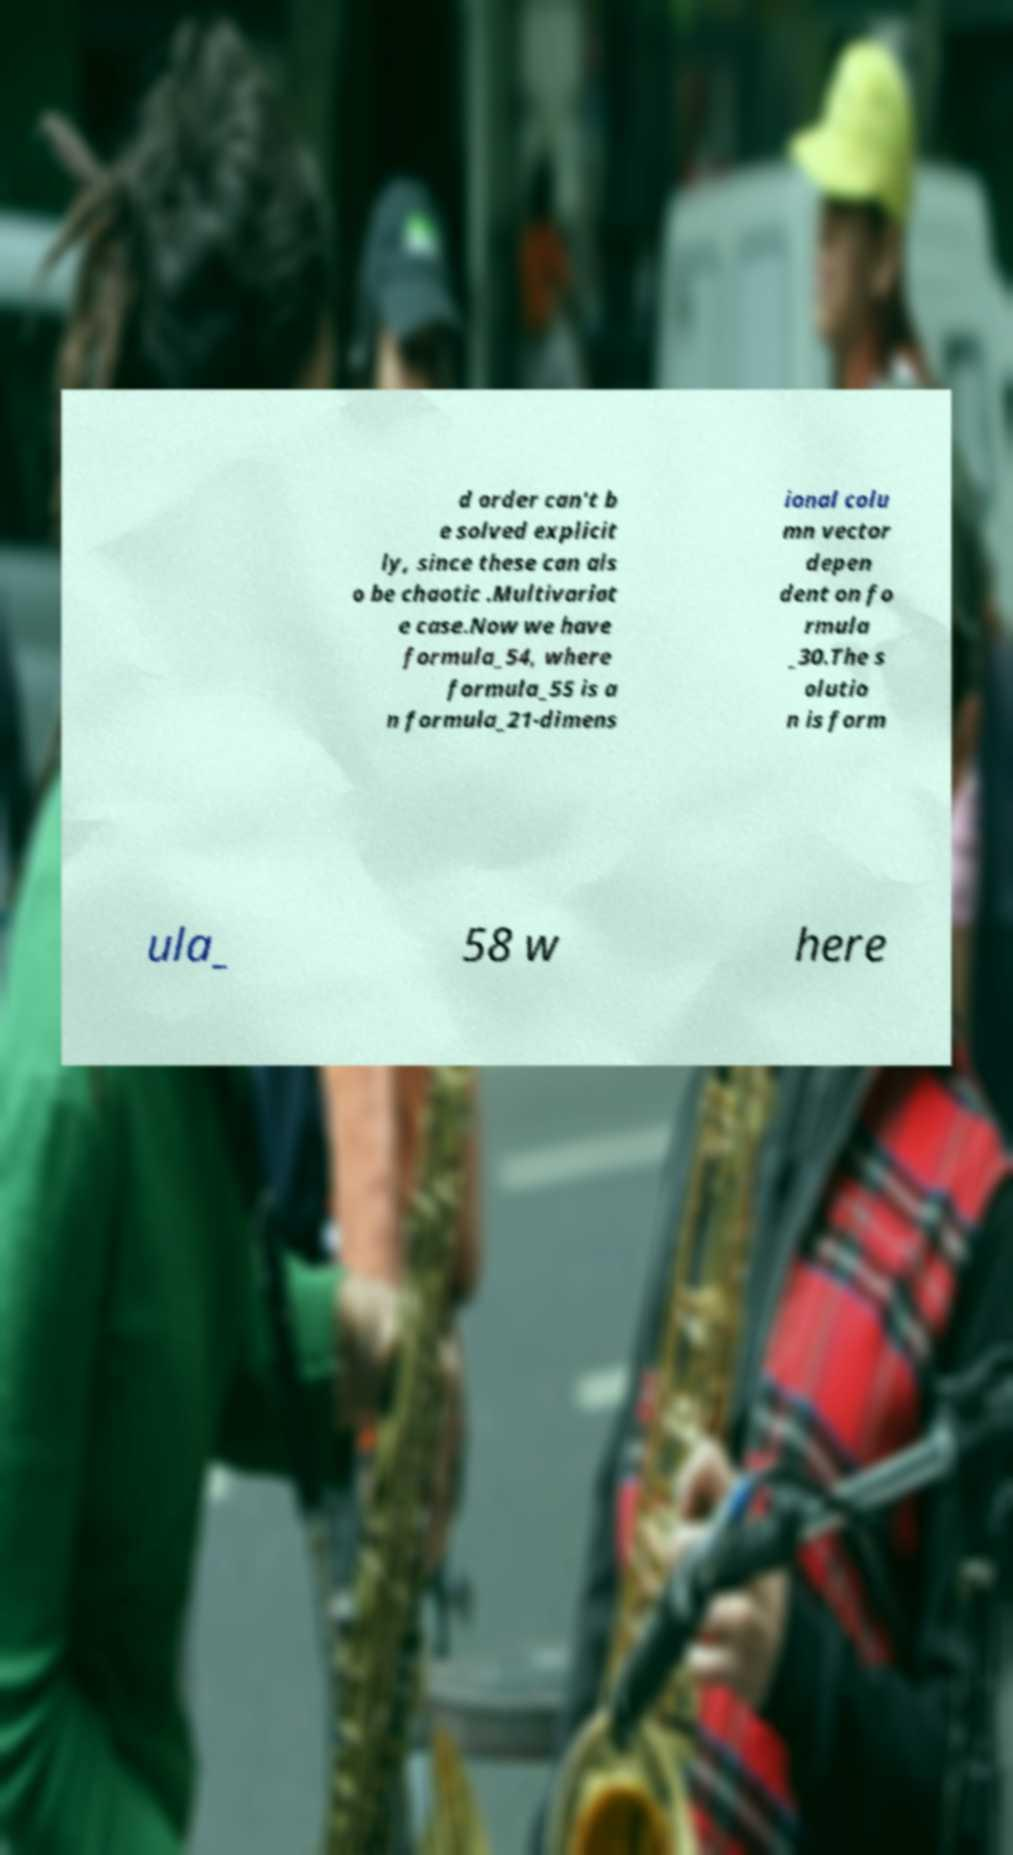There's text embedded in this image that I need extracted. Can you transcribe it verbatim? d order can't b e solved explicit ly, since these can als o be chaotic .Multivariat e case.Now we have formula_54, where formula_55 is a n formula_21-dimens ional colu mn vector depen dent on fo rmula _30.The s olutio n is form ula_ 58 w here 